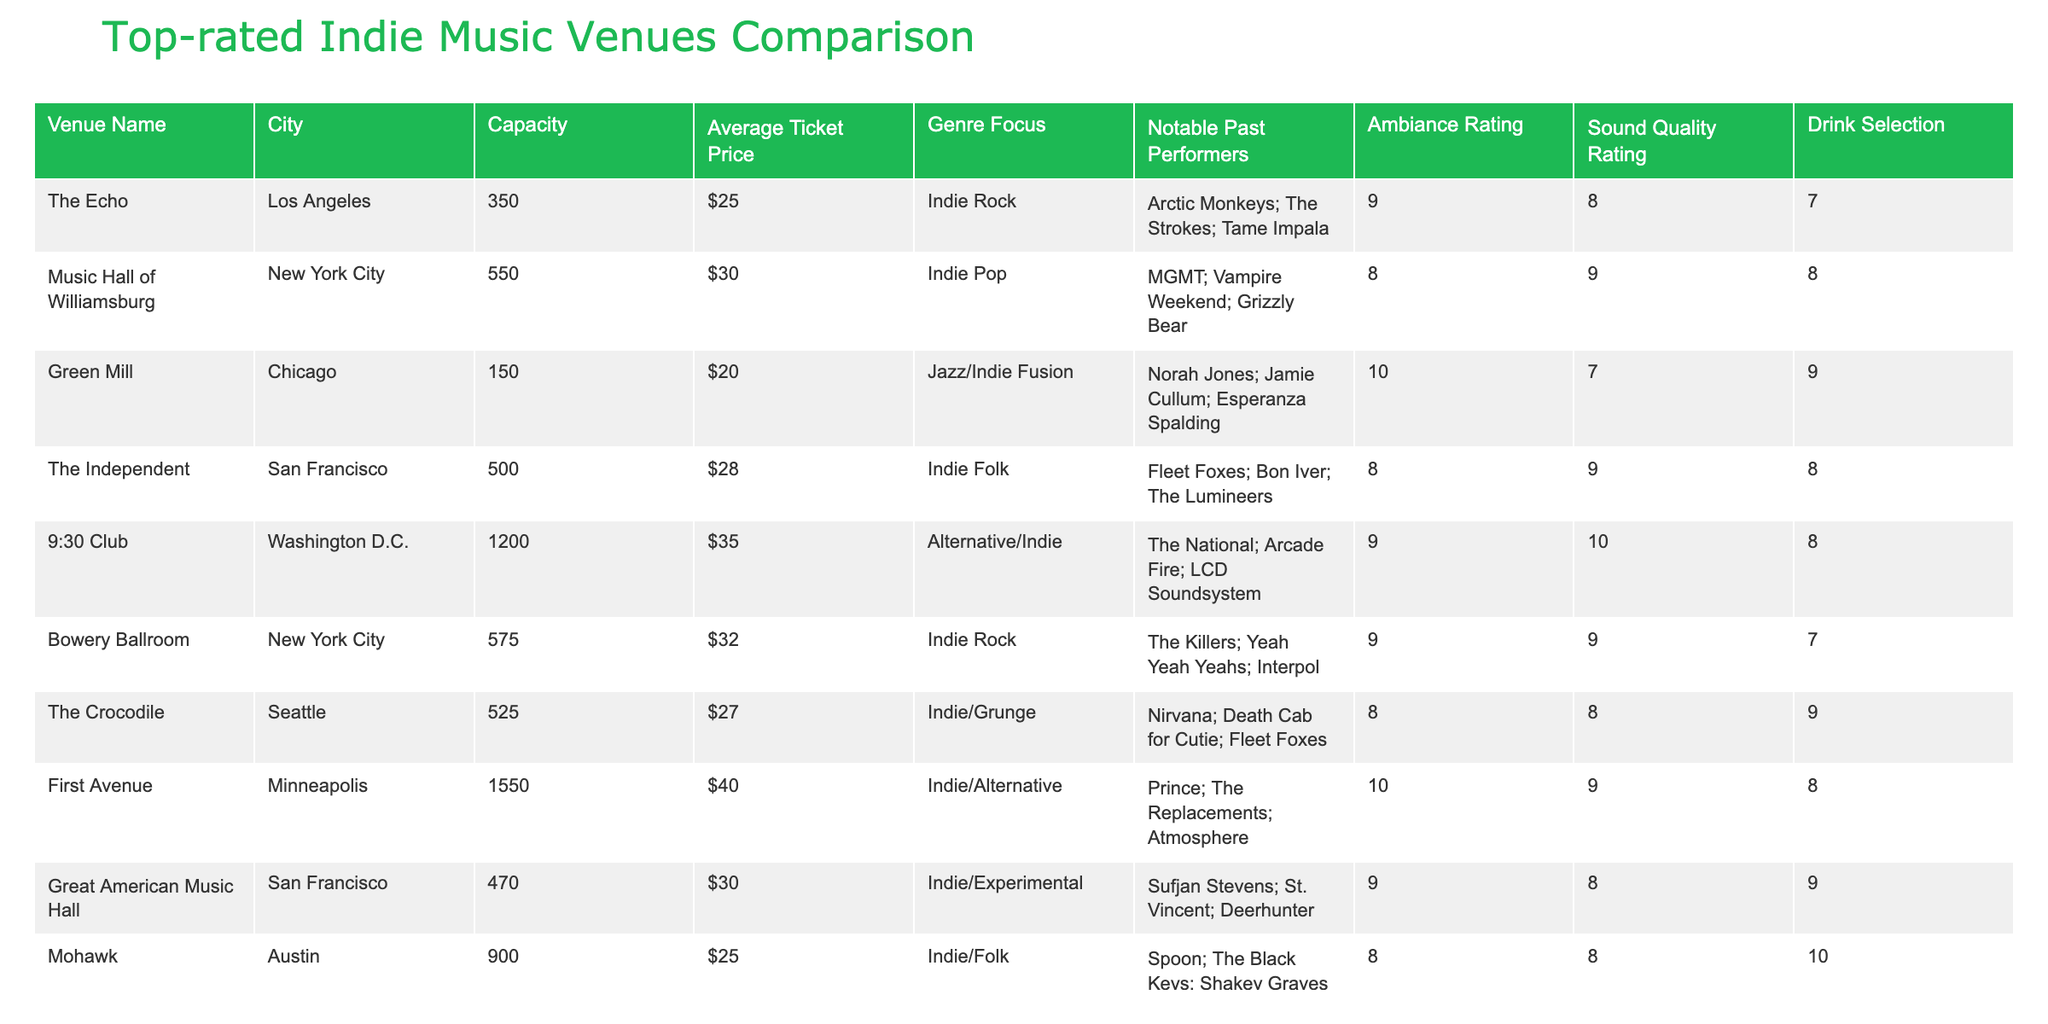What is the capacity of First Avenue? The table lists the capacity of First Avenue as 1550. This information can be found in the 'Capacity' column aligned with First Avenue in the 'Venue Name' row.
Answer: 1550 Which venue in Chicago has the highest ambiance rating? The Green Mill, located in Chicago, has an ambiance rating of 10, which is the highest among the venues listed. This is found by comparing the ambiance ratings in the 'Ambiance Rating' column.
Answer: Green Mill What is the average ticket price of venues located in San Francisco? There are two venues in San Francisco: The Independent ($28) and Great American Music Hall ($30). To find the average, add these values: 28 + 30 = 58, then divide by 2, giving an average ticket price of 29.
Answer: $29 Is the sound quality rating of the 9:30 Club higher than that of the Bowery Ballroom? The 9:30 Club has a sound quality rating of 10, while the Bowery Ballroom has a rating of 9. Since 10 is greater than 9, the statement is true.
Answer: Yes Which city has the venue with the highest average ticket price? First Avenue in Minneapolis has the highest average ticket price at $40. This is determined by inspecting the 'Average Ticket Price' column for all venues and identifying the maximum price.
Answer: Minneapolis 